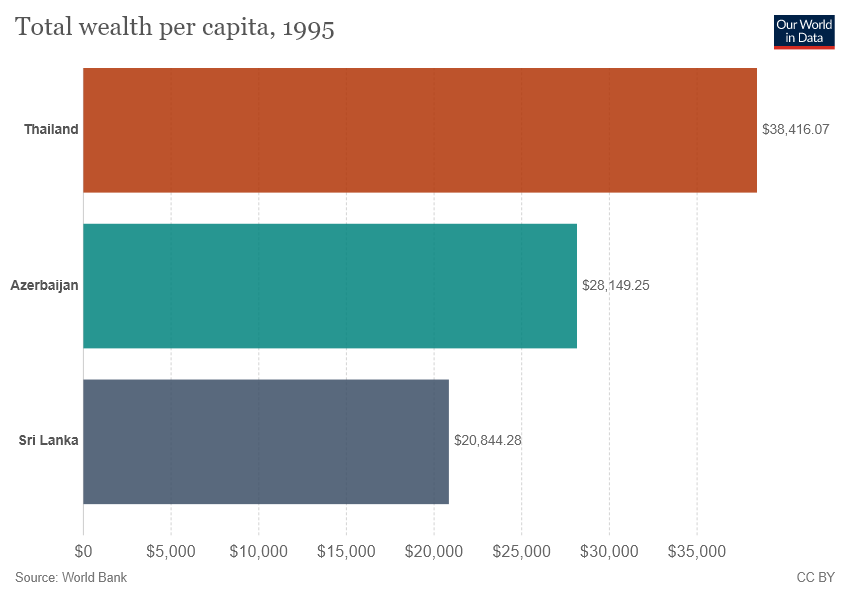List a handful of essential elements in this visual. The sum of Sri Lanka and Azerbaijan is 48,993.53. The place with a total wealth per capita of 38,416.07 is Thailand. 